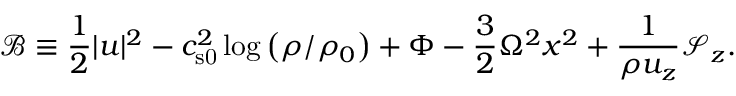Convert formula to latex. <formula><loc_0><loc_0><loc_500><loc_500>\mathcal { B } \equiv \frac { 1 } { 2 } | u | ^ { 2 } - c _ { s 0 } ^ { 2 } \log { \left ( \rho / \rho _ { 0 } \right ) } + \Phi - \frac { 3 } { 2 } \Omega ^ { 2 } x ^ { 2 } + \frac { 1 } { \rho u _ { z } } \mathcal { S } _ { z } .</formula> 